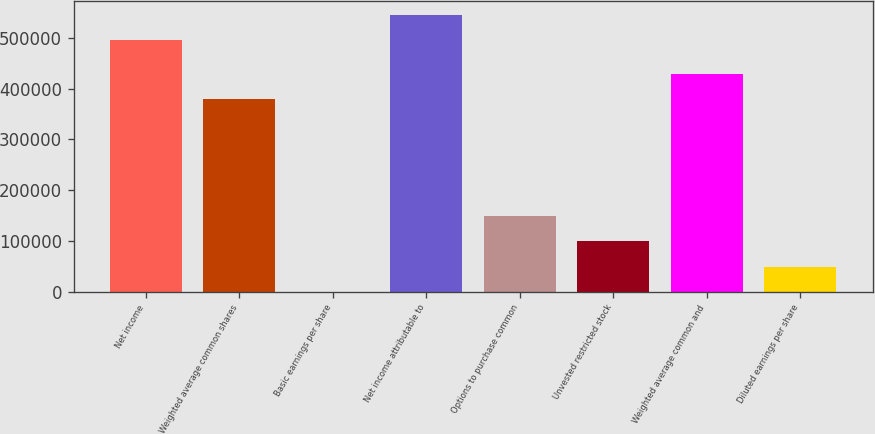Convert chart to OTSL. <chart><loc_0><loc_0><loc_500><loc_500><bar_chart><fcel>Net income<fcel>Weighted average common shares<fcel>Basic earnings per share<fcel>Net income attributable to<fcel>Options to purchase common<fcel>Unvested restricted stock<fcel>Weighted average common and<fcel>Diluted earnings per share<nl><fcel>495000<fcel>379749<fcel>1.3<fcel>544500<fcel>148501<fcel>99001<fcel>429249<fcel>49501.2<nl></chart> 